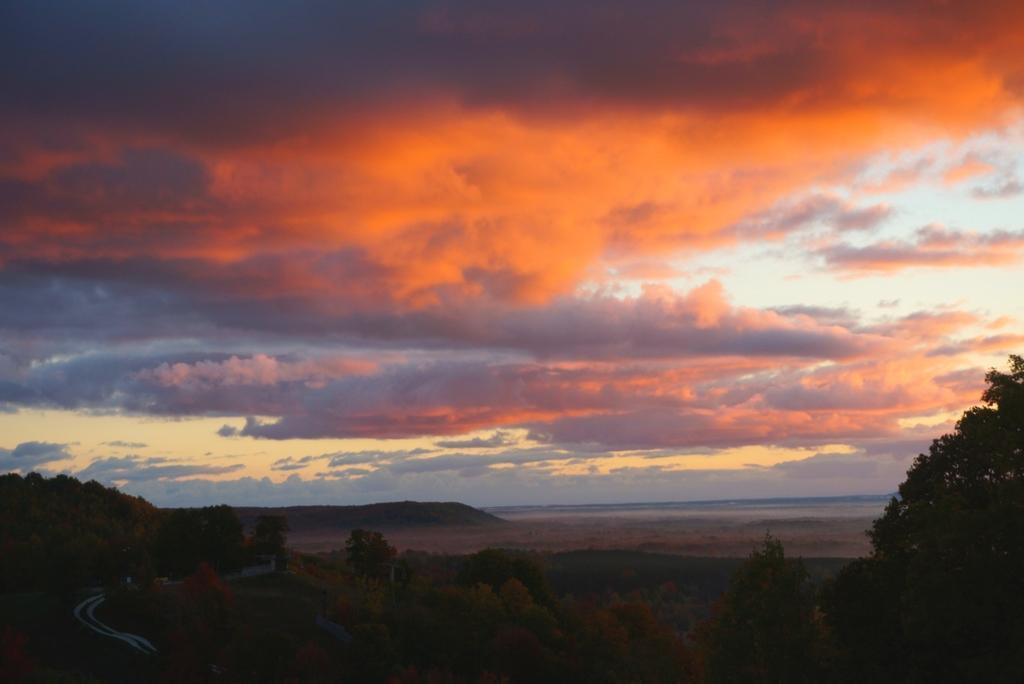Please provide a concise description of this image. In this image we can see some trees and at the background of the image there are some mountains and orange color sky. 